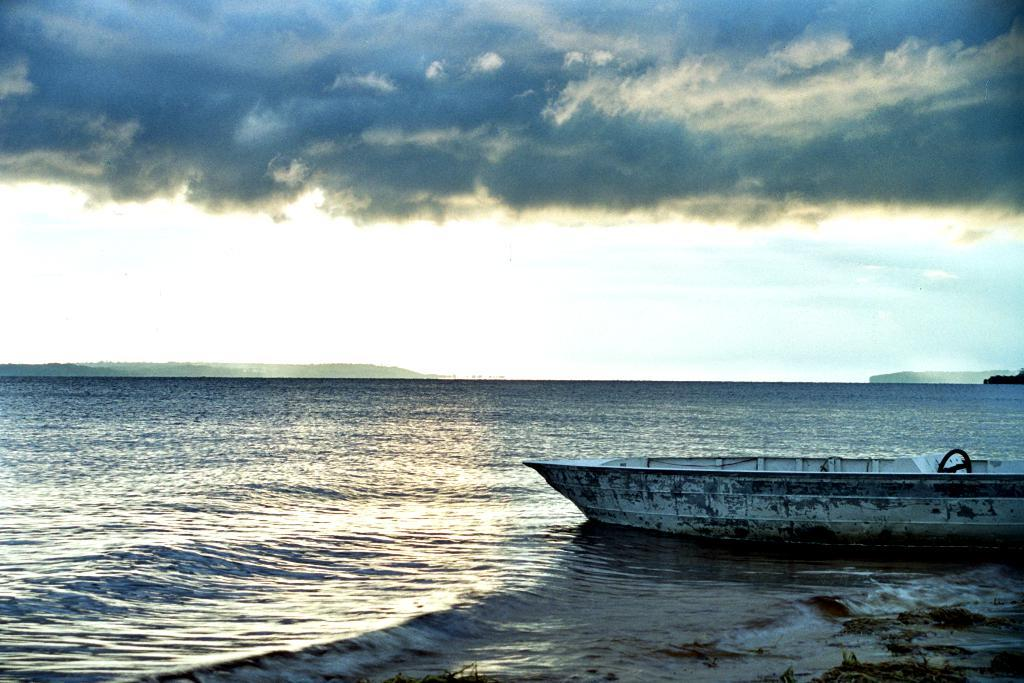What is the main subject of the image? There is a boat in the image. Where is the boat located? The boat is in the ocean. What can be seen in the background of the image? Hills are visible in the background, and they are on either side of the boat. What is visible in the sky in the image? The sky is visible in the image, and clouds are present. What type of eggnog is being served on the boat in the image? There is no eggnog present in the image; it features a boat in the ocean with hills in the background and clouds in the sky. 